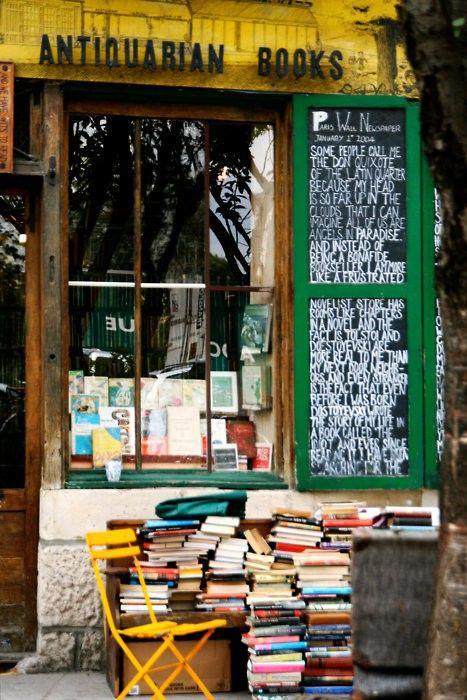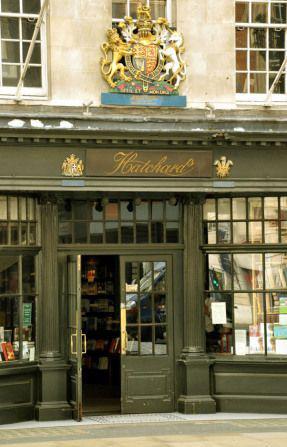The first image is the image on the left, the second image is the image on the right. For the images displayed, is the sentence "The door in the image on the right is open." factually correct? Answer yes or no. Yes. 